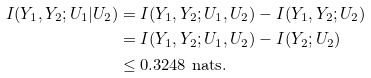<formula> <loc_0><loc_0><loc_500><loc_500>I ( Y _ { 1 } , Y _ { 2 } ; U _ { 1 } | U _ { 2 } ) & = I ( Y _ { 1 } , Y _ { 2 } ; U _ { 1 } , U _ { 2 } ) - I ( Y _ { 1 } , Y _ { 2 } ; U _ { 2 } ) \\ & = I ( Y _ { 1 } , Y _ { 2 } ; U _ { 1 } , U _ { 2 } ) - I ( Y _ { 2 } ; U _ { 2 } ) \\ & \leq 0 . 3 2 4 8 \ \text {nats} .</formula> 